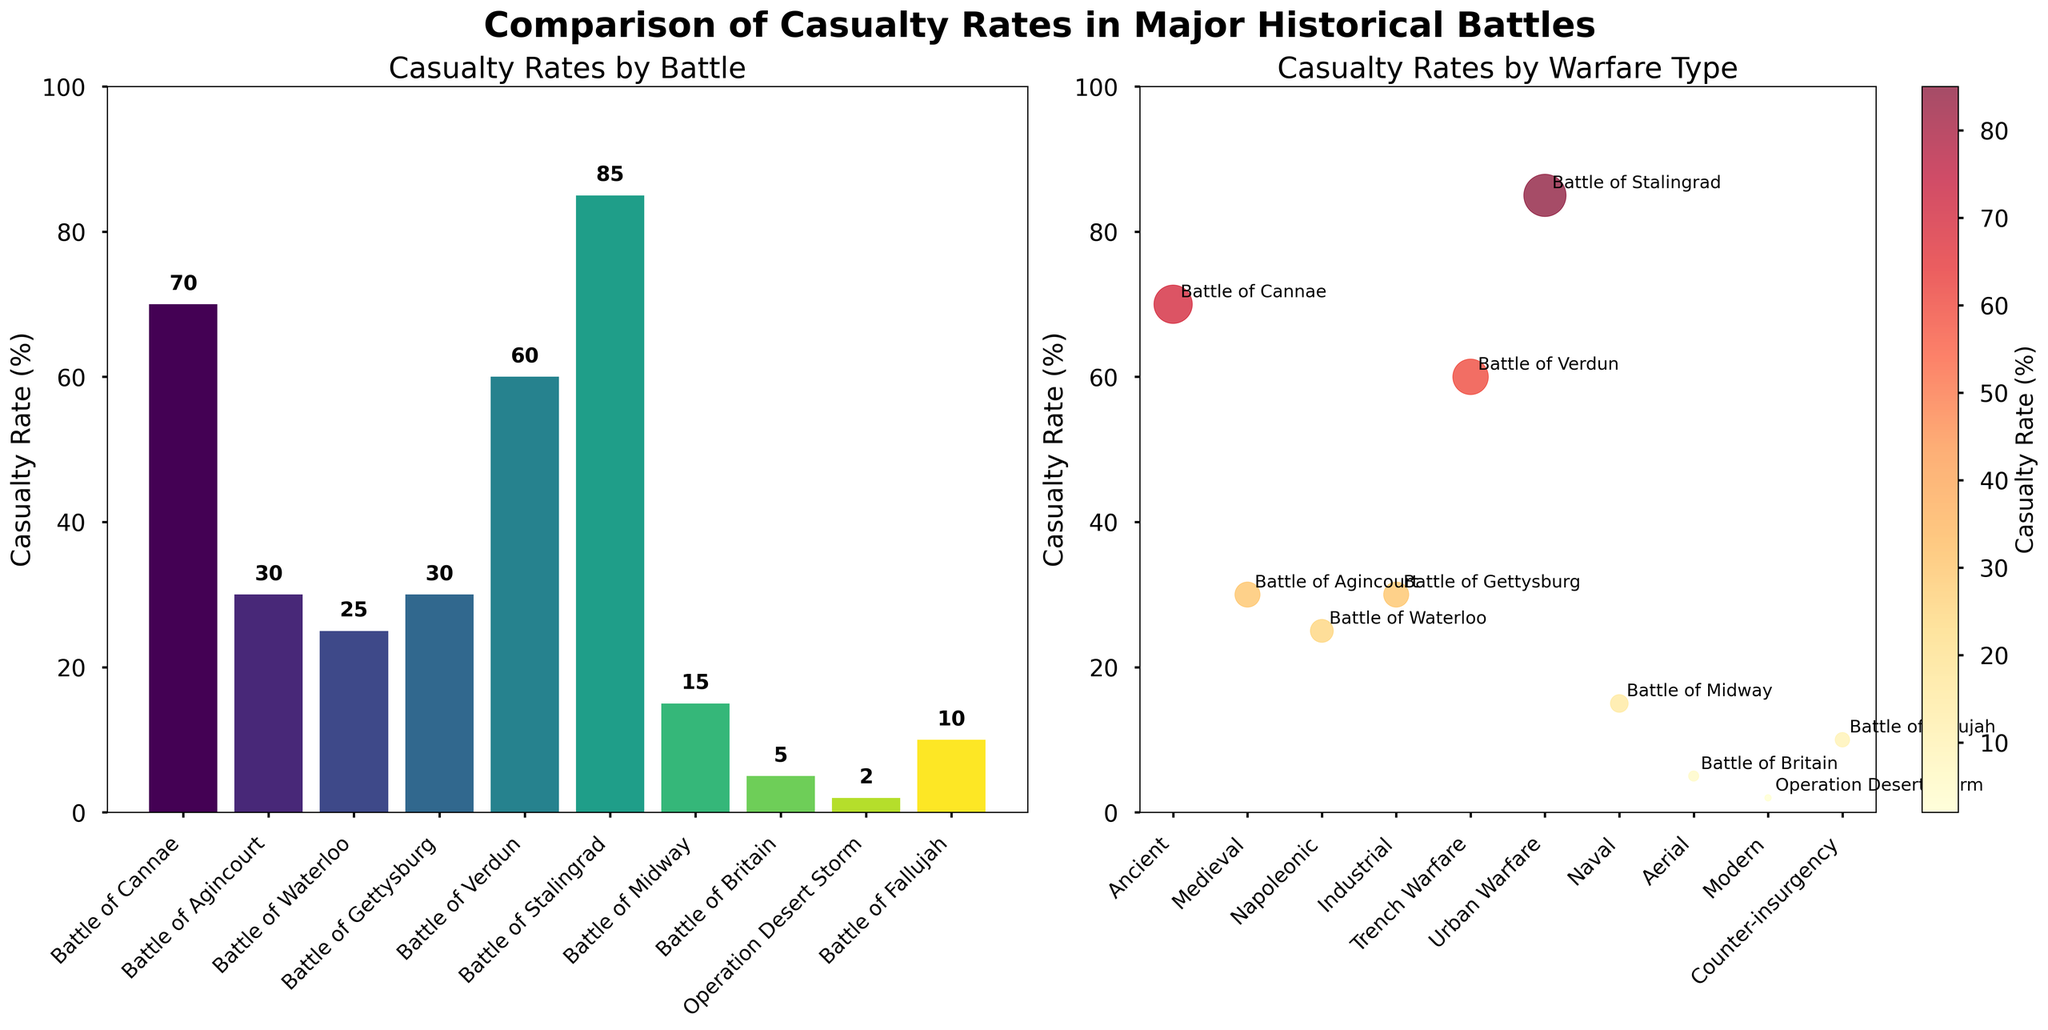What is the title of the figure? The title is found at the top center of the figure. It provides an overview of what the figure is about.
Answer: Comparison of Casualty Rates in Major Historical Battles Which battle has the highest casualty rate? Look for the battle with the tallest bar in the bar plot or the highest point in the scatter plot.
Answer: Battle of Stalingrad What is the casualty rate for the Battle of Agincourt? Identify the corresponding bar in the bar plot or point in the scatter plot labeled 'Battle of Agincourt'.
Answer: 30% How many different types of warfare are shown in the scatter plot? Count the distinct categories on the x-axis of the scatter plot.
Answer: 9 Which battle had a casualty rate lower than 10%? Find the bars in the bar plot or points in the scatter plot with casualty rates lower than 10%.
Answer: Operation Desert Storm What is the average casualty rate across all battles? Sum all the casualty rates and divide by the number of battles (10). Calculation steps: (70 + 30 + 25 + 30 + 60 + 85 + 15 + 5 + 2 + 10) / 10 = 33.2
Answer: 33.2% Which type of warfare resulted in the highest casualty rate? Locate the highest point in the scatter plot and identify its corresponding type of warfare.
Answer: Urban Warfare Compare the casualty rates between the Battle of Verdun and the Battle of Britain. Identify and compare the heights of the bars or points for these two battles.
Answer: The Battle of Verdun (60%) has a higher casualty rate than the Battle of Britain (5%) What is the sum of the casualty rates for ancient, medieval, and napoleonic battles? Add the casualty rates for Battle of Cannae, Battle of Agincourt, and Battle of Waterloo. Calculation steps: 70 + 30 + 25 = 125
Answer: 125% Which type of warfare has the most battles represented in the figure? Count the occurrences of each type of warfare in the scatter plot and determine the maximum. Both "Industrial" and "Medieval" appear once, so all types of warfare are equally represented.
Answer: All types equally represented 